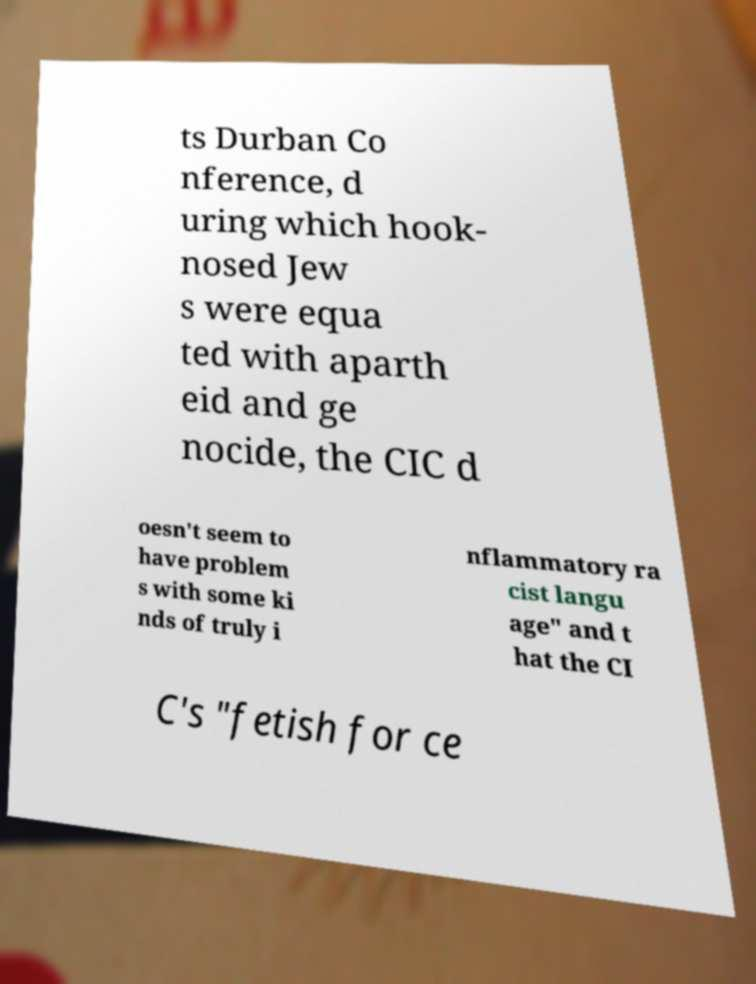Please read and relay the text visible in this image. What does it say? ts Durban Co nference, d uring which hook- nosed Jew s were equa ted with aparth eid and ge nocide, the CIC d oesn't seem to have problem s with some ki nds of truly i nflammatory ra cist langu age" and t hat the CI C's "fetish for ce 